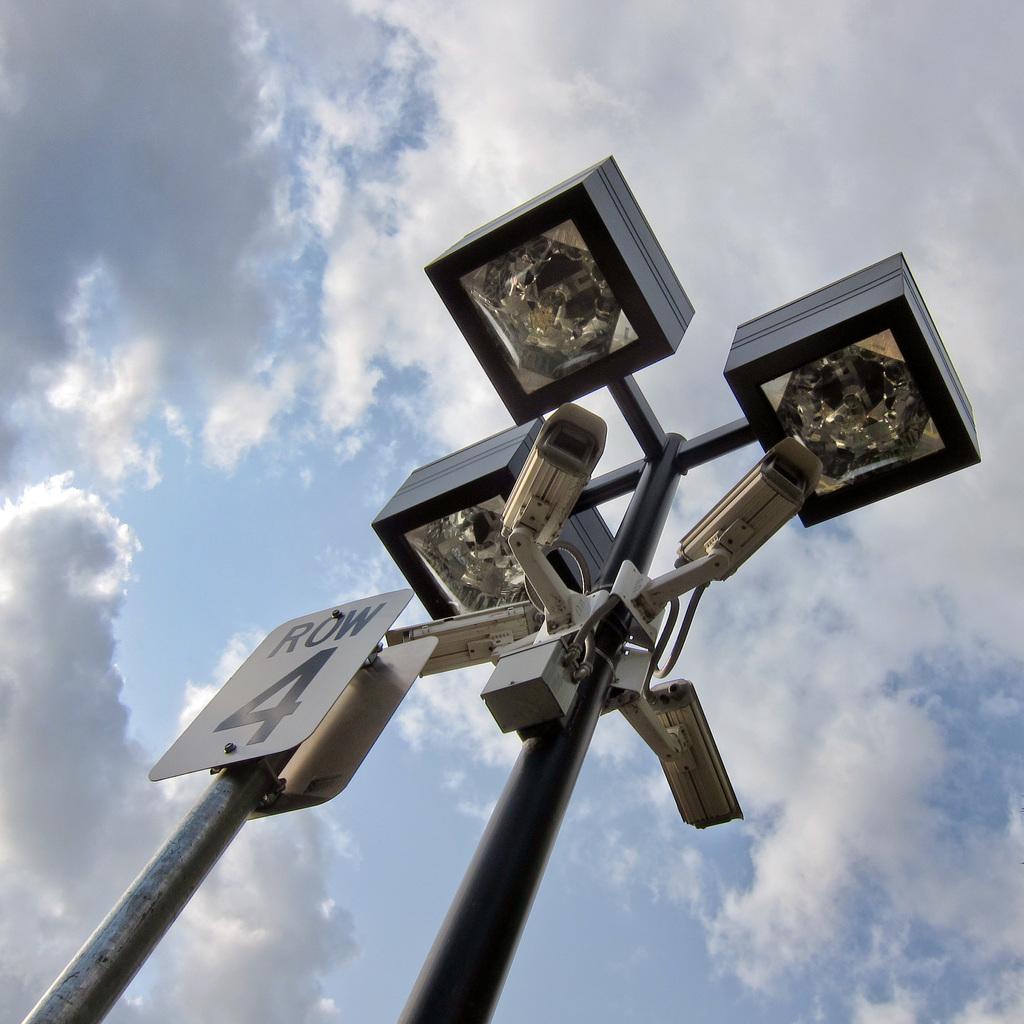Describe this image in one or two sentences. In this image there are poles, board, lights, cameras, and some box and in the background there is sky. 